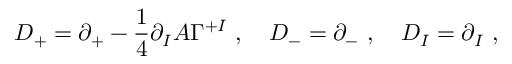Convert formula to latex. <formula><loc_0><loc_0><loc_500><loc_500>D _ { + } = \partial _ { + } - \frac { 1 } { 4 } \partial _ { I } A \Gamma ^ { + I } , D _ { - } = \partial _ { - } , D _ { I } = \partial _ { I } ,</formula> 